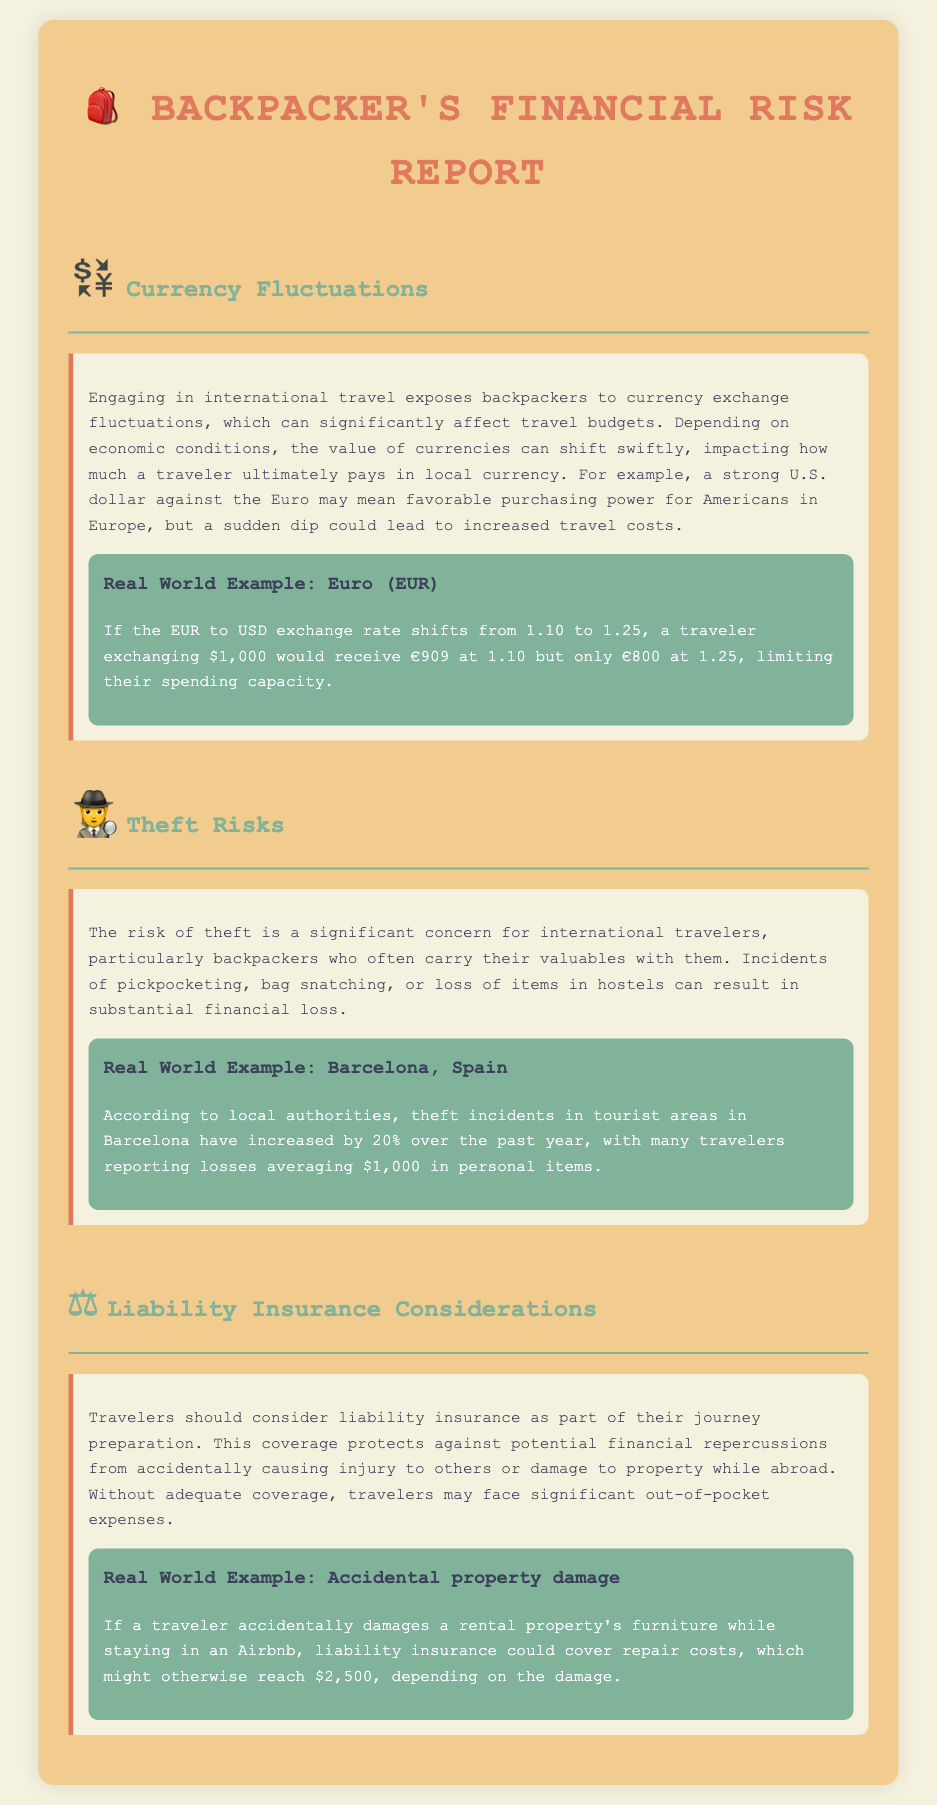what is the risk associated with currency fluctuations? Currency fluctuations can significantly affect travel budgets and purchasing power.
Answer: purchasing power what was the example currency exchange rate? The document presents an example where the EUR to USD exchange rate shifts from 1.10 to 1.25.
Answer: 1.10 to 1.25 how much can a traveler lose to theft on average in Barcelona? The document states that travelers report average losses of $1,000 in personal items due to theft.
Answer: $1,000 what type of insurance should travelers consider? Travelers should consider liability insurance to protect against financial repercussions from causing injury or damage.
Answer: liability insurance what could be the repair costs for accidental property damage? The document mentions that repair costs for accidental damage might reach $2,500.
Answer: $2,500 how much did theft incidents increase by in Barcelona? According to the document, theft incidents in tourist areas have increased by 20% over the past year.
Answer: 20% what is the main concern for backpackers regarding theft? Backpackers carry their valuables with them, making them a significant target for theft.
Answer: valuables what type of financial loss does liability insurance cover? Liability insurance covers financial repercussions from accidentally causing injury or damage while abroad.
Answer: injury or damage what does the risk of currency fluctuations impact? Currency fluctuations impact how much a traveler ultimately pays in local currency.
Answer: travel costs 